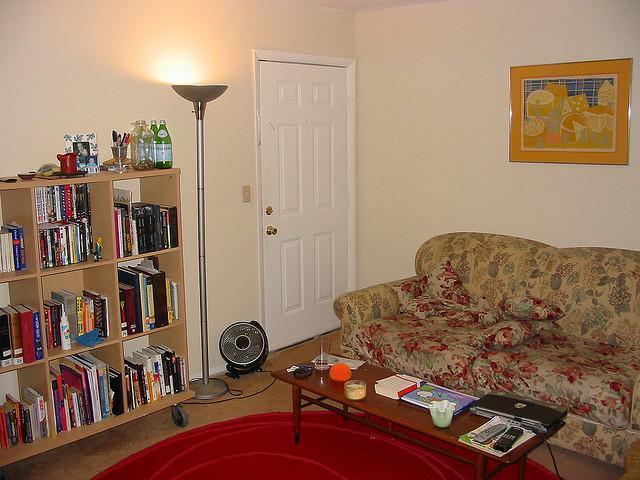Which electronic device is likely located in front of the coffee table?
Choose the right answer from the provided options to respond to the question.
Options: Television, record player, telephone, stereo. Television. 